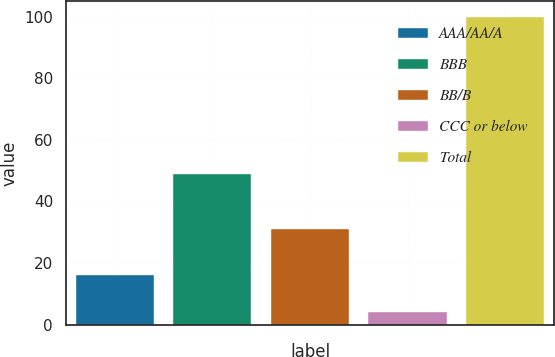Convert chart. <chart><loc_0><loc_0><loc_500><loc_500><bar_chart><fcel>AAA/AA/A<fcel>BBB<fcel>BB/B<fcel>CCC or below<fcel>Total<nl><fcel>16<fcel>49<fcel>31<fcel>4<fcel>100<nl></chart> 